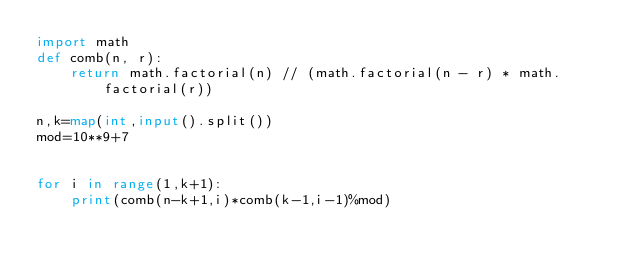<code> <loc_0><loc_0><loc_500><loc_500><_Python_>import math
def comb(n, r):
    return math.factorial(n) // (math.factorial(n - r) * math.factorial(r))

n,k=map(int,input().split())
mod=10**9+7


for i in range(1,k+1):
    print(comb(n-k+1,i)*comb(k-1,i-1)%mod)</code> 